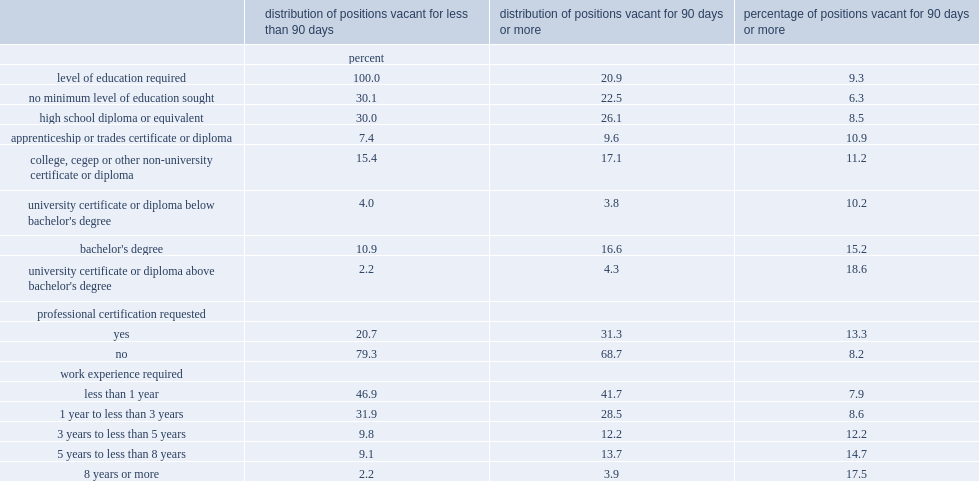In 2016, how many percent of long-term job vacancies were positions for which the employer did not specify any educational requirements? 22.5. How many percent of acancies for jobs requiring a bachelor's degree were long-term job vacancies? 15.2. How many times of the proportion recorded among positions requiring a graduate degree is higher than the proportion recorded among positions with no educational requirements? 2.952381. How many percent of vacancies for positions requiring at least eight years of experience had been vacant for 90 days or more? 17.5. 